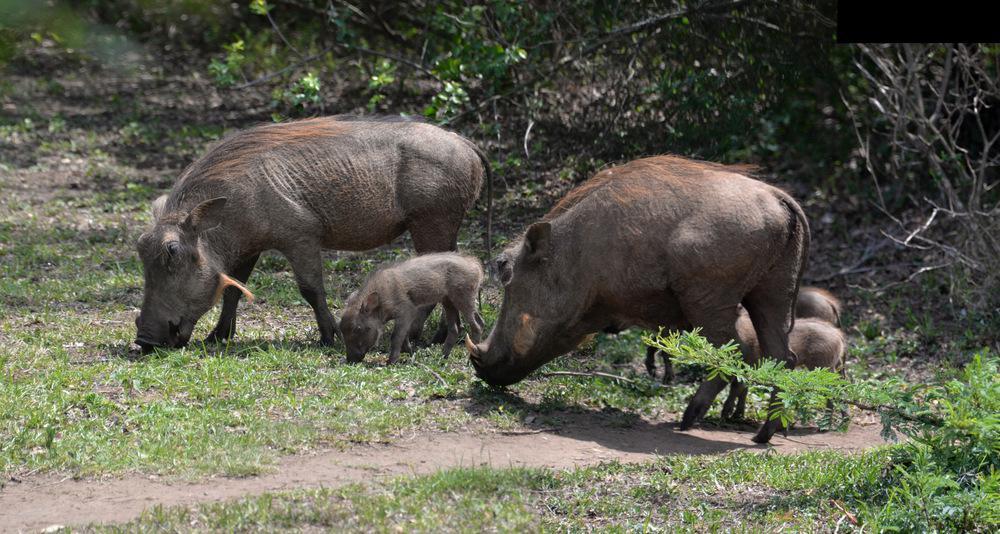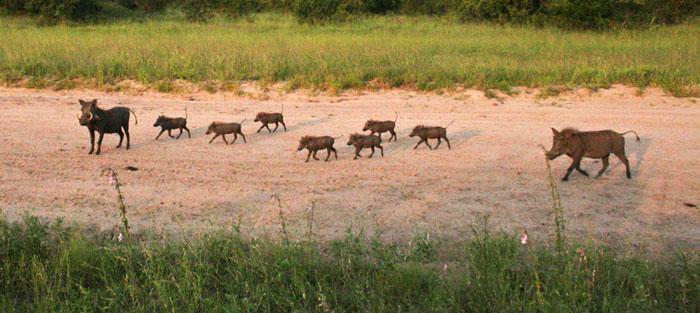The first image is the image on the left, the second image is the image on the right. For the images shown, is this caption "An image shows at least four young warthogs and an adult moving along a wide dirt path flanked by grass." true? Answer yes or no. Yes. The first image is the image on the left, the second image is the image on the right. Analyze the images presented: Is the assertion "The right image contains exactly five warthogs." valid? Answer yes or no. No. 